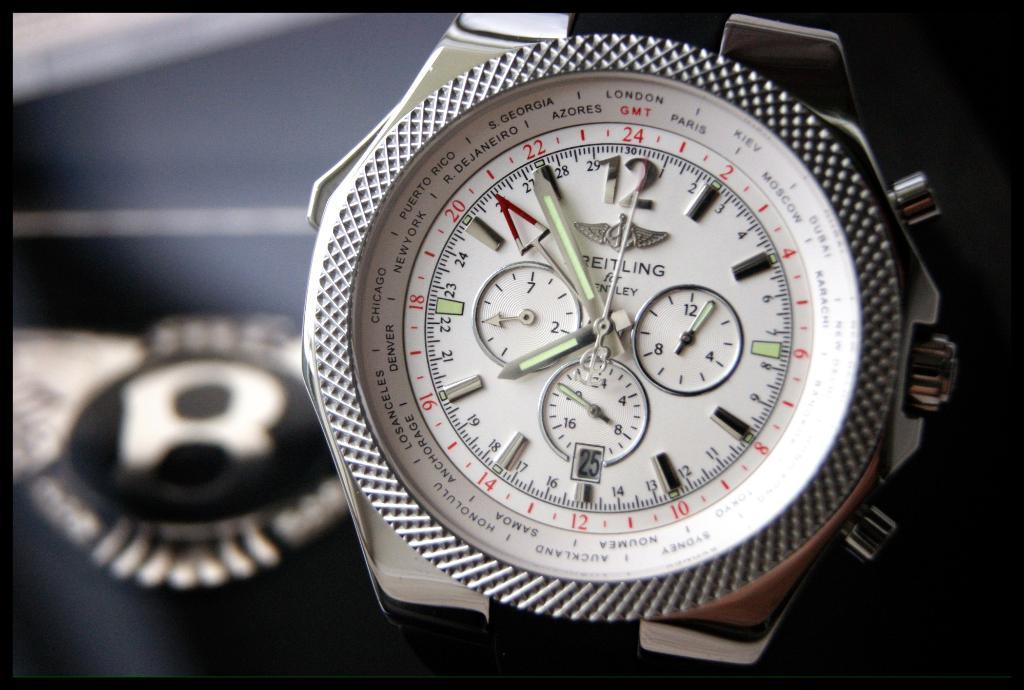<image>
Relay a brief, clear account of the picture shown. A watch face lists several cities, including London and Paris, around its dial. 